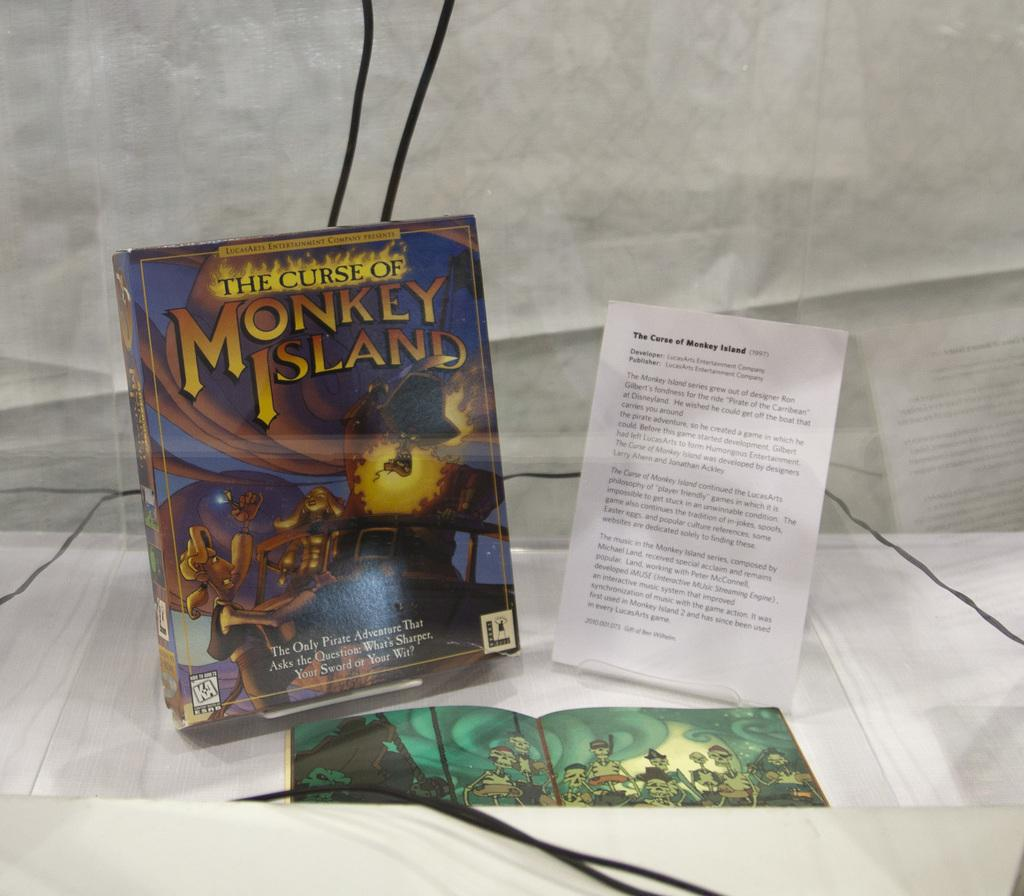<image>
Relay a brief, clear account of the picture shown. A DVD is titled The Curse of Monkey Island. 